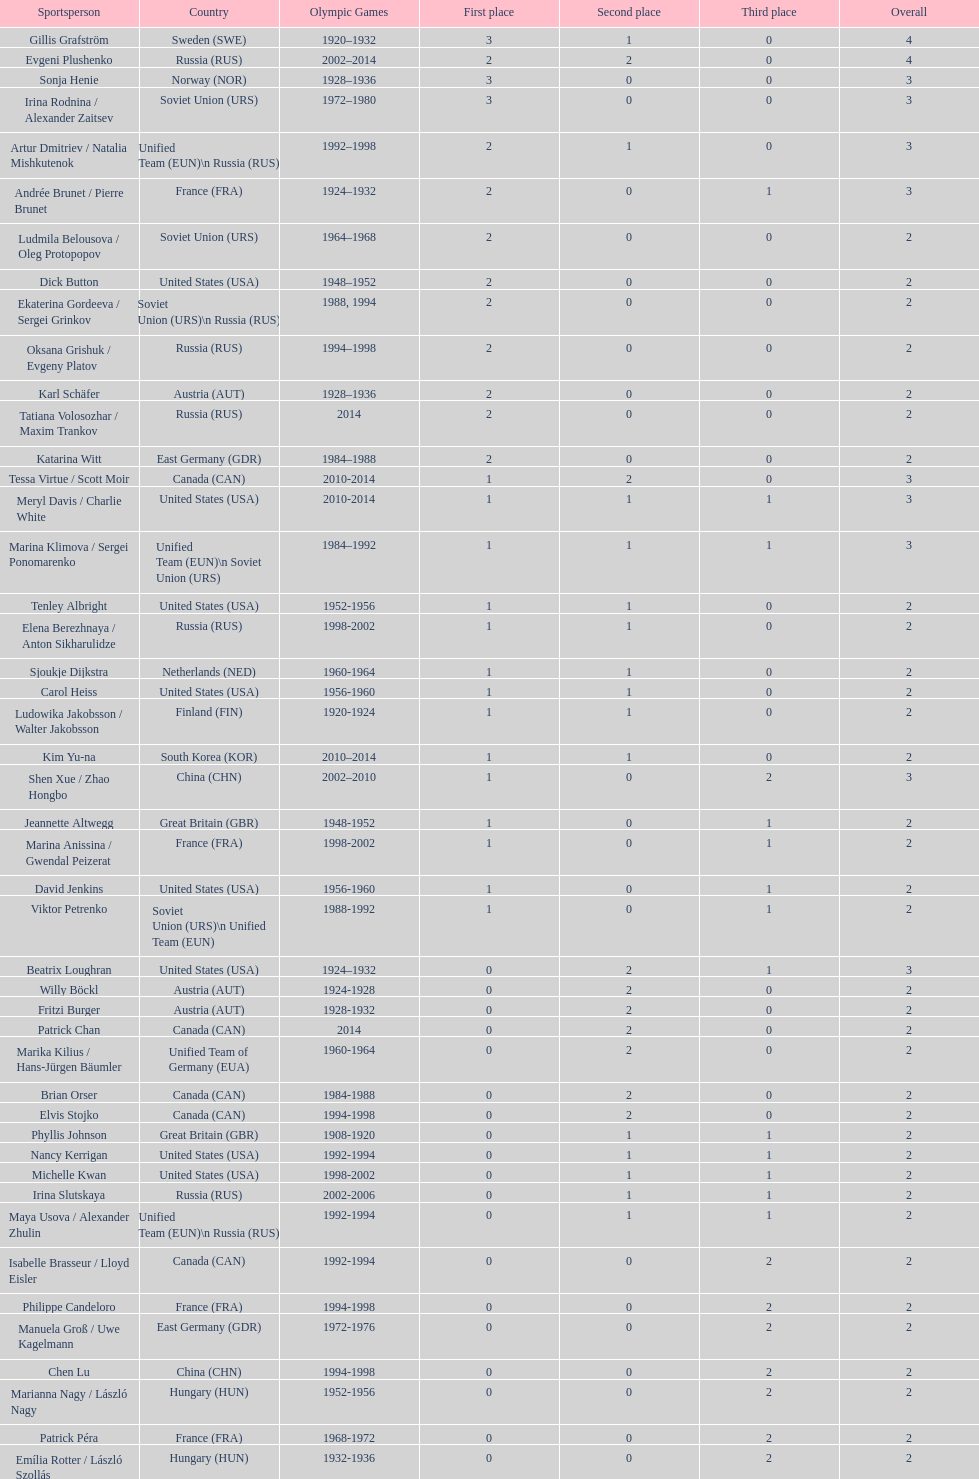Which athlete was from south korea after the year 2010? Kim Yu-na. 